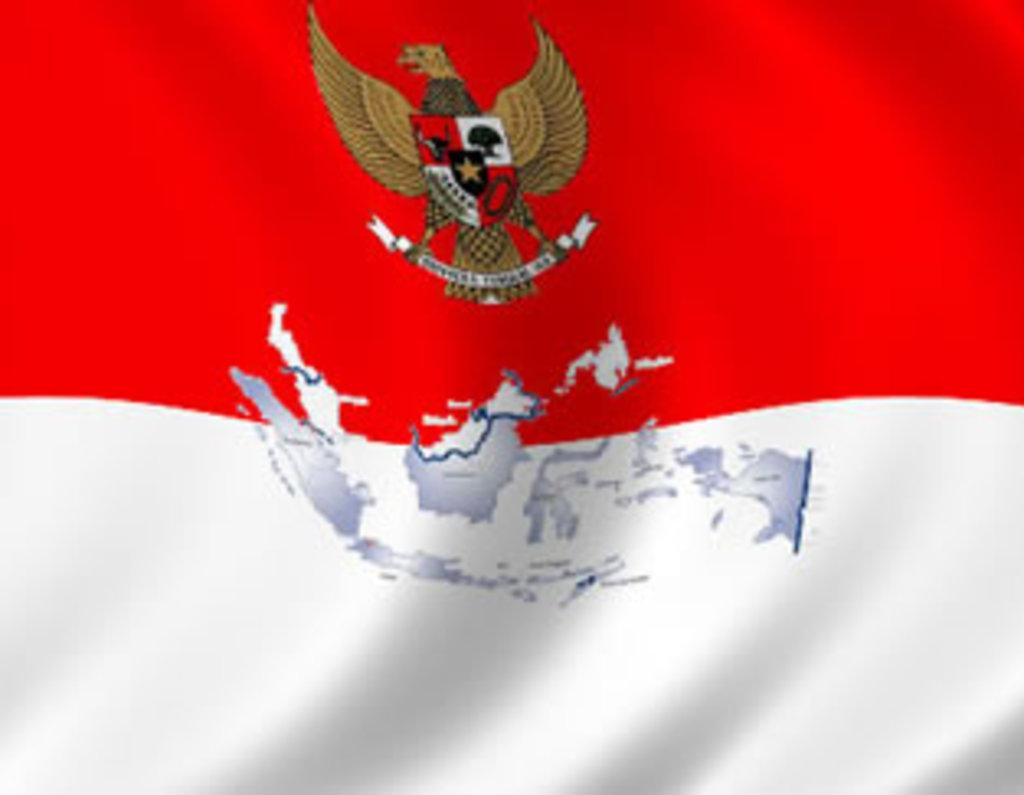What is the main object featured in the image? There is a flag in the image. What design or pattern is on the flag? The flag has a map on it. Are there any animals depicted on the flag? Yes, there is a bird on the flag. What colors are used for the flag? The flag is red and white in color. How many boys are holding the wrench in the image? There are no boys or wrenches present in the image; it features a flag with a map, a bird, and the colors red and white. 